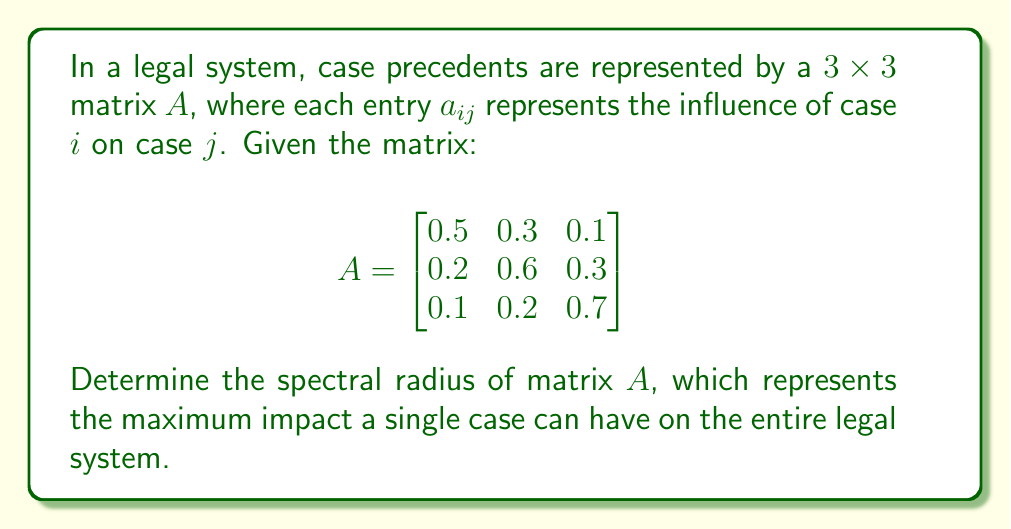Solve this math problem. To find the spectral radius of matrix $A$, we need to follow these steps:

1) First, we need to find the characteristic equation of $A$:
   $det(A - \lambda I) = 0$

2) Expanding this:
   $$\begin{vmatrix}
   0.5-\lambda & 0.3 & 0.1 \\
   0.2 & 0.6-\lambda & 0.3 \\
   0.1 & 0.2 & 0.7-\lambda
   \end{vmatrix} = 0$$

3) Calculating the determinant:
   $(0.5-\lambda)[(0.6-\lambda)(0.7-\lambda)-0.06] - 0.3[0.2(0.7-\lambda)-0.03] + 0.1[0.2(0.6-\lambda)-0.09] = 0$

4) Simplifying:
   $-\lambda^3 + 1.8\lambda^2 - 0.93\lambda + 0.134 = 0$

5) This cubic equation can be solved using numerical methods. The roots (eigenvalues) are approximately:
   $\lambda_1 \approx 0.9397$
   $\lambda_2 \approx 0.4985$
   $\lambda_3 \approx 0.3618$

6) The spectral radius is the maximum absolute value of the eigenvalues:
   $\rho(A) = \max(|\lambda_1|, |\lambda_2|, |\lambda_3|) \approx 0.9397$
Answer: $0.9397$ 